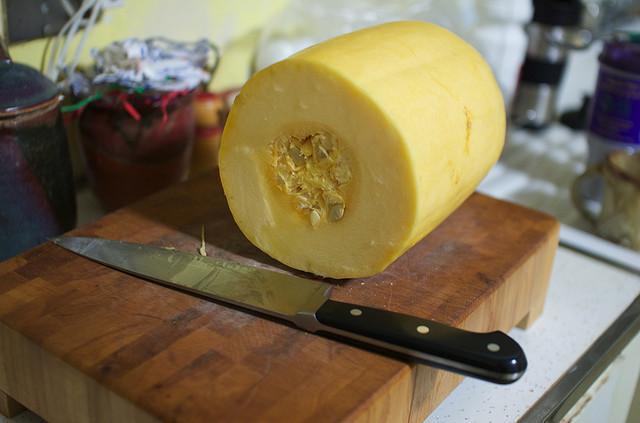How many cars are in the intersection?
Give a very brief answer. 0. 